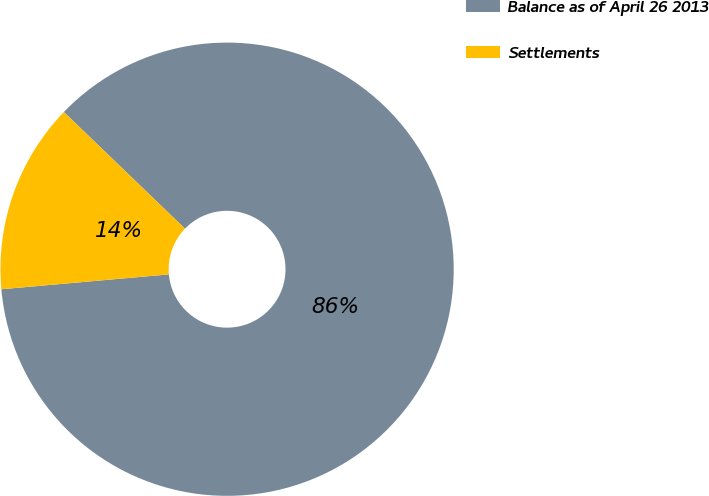Convert chart to OTSL. <chart><loc_0><loc_0><loc_500><loc_500><pie_chart><fcel>Balance as of April 26 2013<fcel>Settlements<nl><fcel>86.39%<fcel>13.61%<nl></chart> 